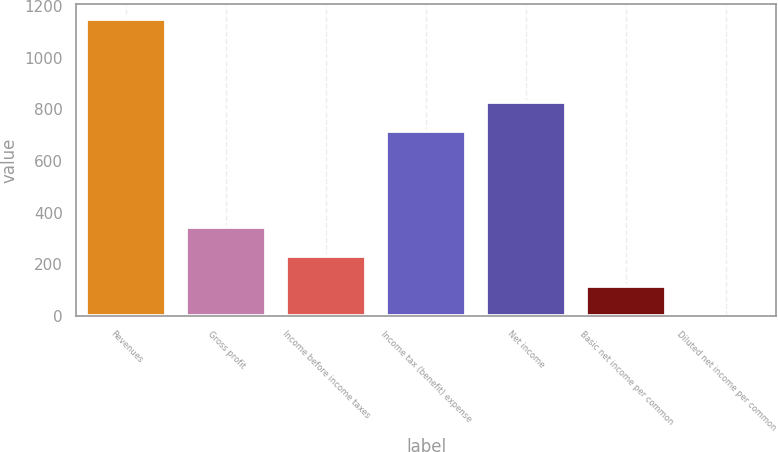Convert chart to OTSL. <chart><loc_0><loc_0><loc_500><loc_500><bar_chart><fcel>Revenues<fcel>Gross profit<fcel>Income before income taxes<fcel>Income tax (benefit) expense<fcel>Net income<fcel>Basic net income per common<fcel>Diluted net income per common<nl><fcel>1150<fcel>346.56<fcel>231.78<fcel>715.6<fcel>830.38<fcel>117<fcel>2.22<nl></chart> 